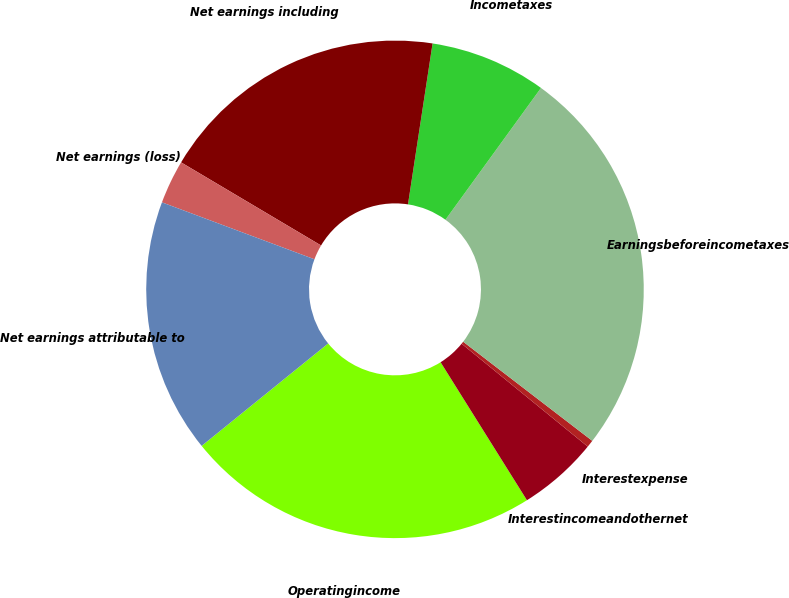Convert chart. <chart><loc_0><loc_0><loc_500><loc_500><pie_chart><fcel>Operatingincome<fcel>Interestincomeandothernet<fcel>Interestexpense<fcel>Earningsbeforeincometaxes<fcel>Incometaxes<fcel>Net earnings including<fcel>Net earnings (loss)<fcel>Net earnings attributable to<nl><fcel>23.07%<fcel>5.21%<fcel>0.47%<fcel>25.44%<fcel>7.57%<fcel>18.89%<fcel>2.84%<fcel>16.52%<nl></chart> 